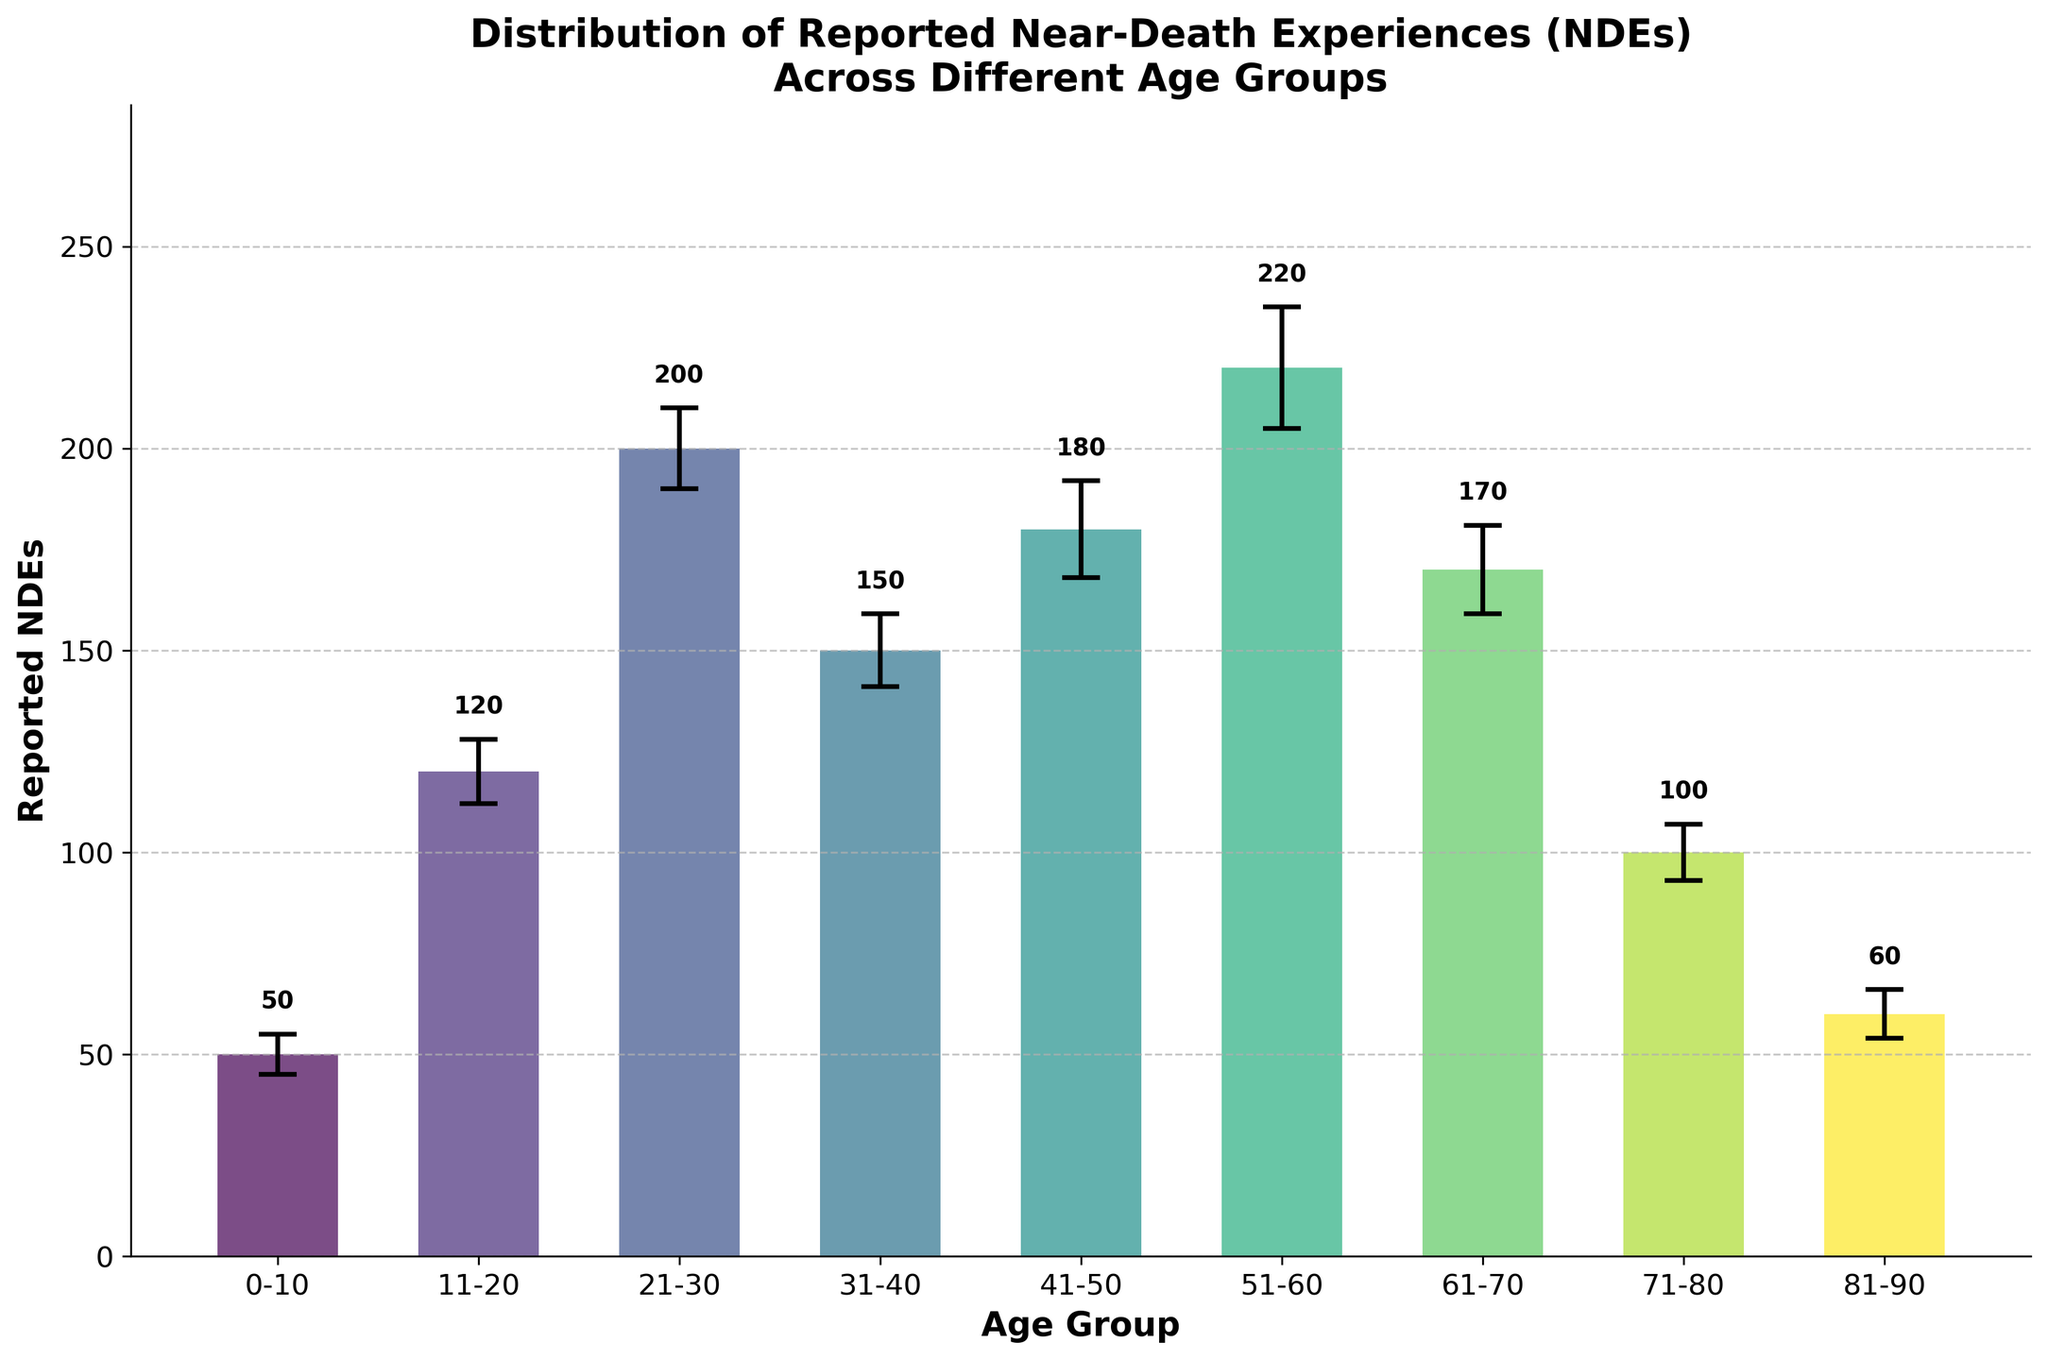What's the title of the figure? The title of the figure is usually prominently displayed at the top and describes what the figure is about. It reads 'Distribution of Reported Near-Death Experiences (NDEs) Across Different Age Groups'.
Answer: Distribution of Reported Near-Death Experiences (NDEs) Across Different Age Groups What's the age group with the highest number of reported NDEs? The age group with the highest bar represents the group with the most reported NDEs. In this case, the bar for the age group 51-60 is the tallest.
Answer: 51-60 Which age group has the smallest certainty level? Certainty levels are indicated by the ± values in the error bars. The smallest error bar is observed in the '0-10' age group with a certainty level of 5.
Answer: 0-10 What's the difference in reported NDEs between the age groups 21-30 and 61-70? The bar heights indicate the number of reported NDEs. For 21-30, it is 200, and for 61-70, it is 170. The difference is calculated as 200 - 170.
Answer: 30 What's the average number of reported NDEs across all age groups? Add up all the reported NDEs and divide by the number of age groups. (50+120+200+150+180+220+170+100+60) / 9 = 1250 / 9.
Answer: ~139 How many age groups reported more than 150 NDEs? Visually count the number of bars exceeding the 150 mark on the y-axis. These age groups are 21-30, 41-50, and 51-60.
Answer: 3 Which age group has the largest error bar? The size of the error bars indicates certainty level. The age group 51-60 has an error bar of ±15, which is the largest.
Answer: 51-60 What's the total number of reported NDEs for the age groups 31-40 and 41-50 combined? Sum the reported NDEs for these two age groups: 150 + 180 = 330.
Answer: 330 Which age group has an error bar close to ±6? By examining the error bars, the age groups 71-80 and 81-90 have error bars of ±7 and ±6, respectively.
Answer: 81-90 Which age groups have exactly 50 and 60 reported NDEs, and what's the difference in their certainty levels? The age groups with 50 and 60 reported NDEs are 0-10 and 81-90, respectively. Their certainty levels are 5 and 6. Difference: 6 - 5 = 1.
Answer: 1 